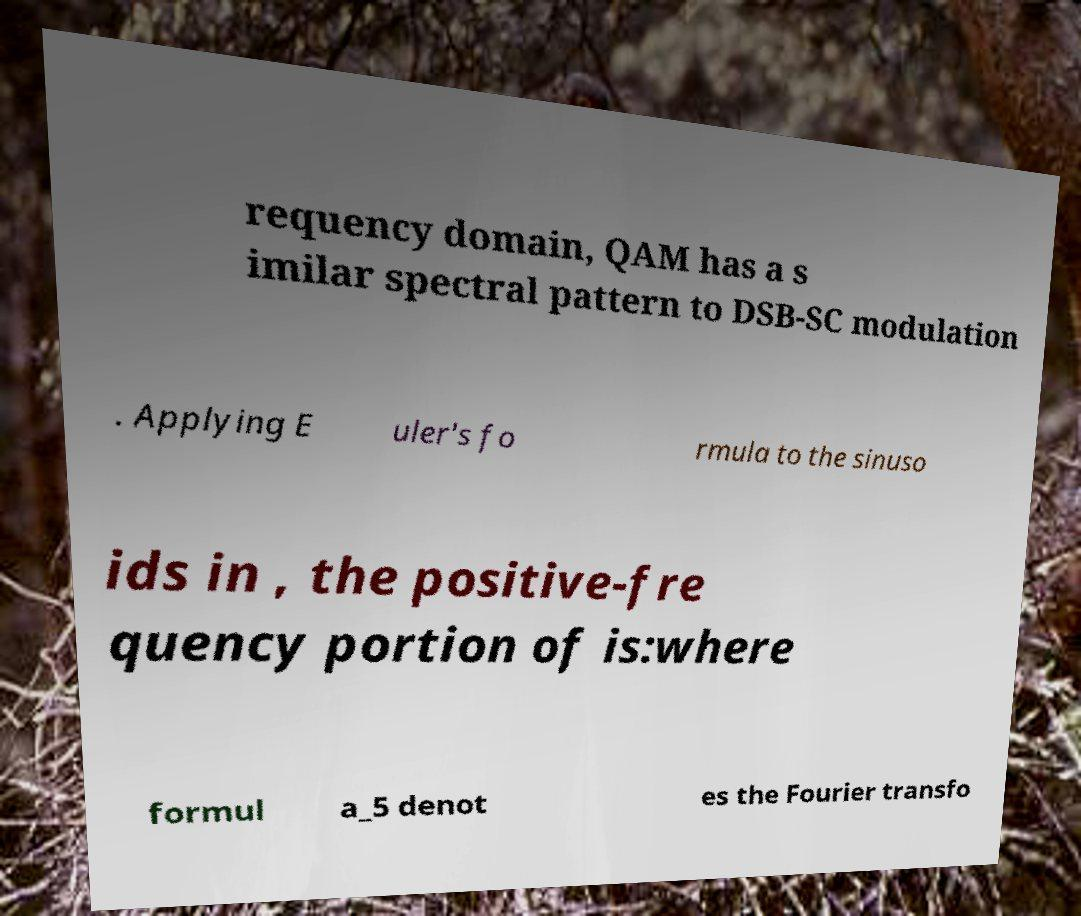Please read and relay the text visible in this image. What does it say? requency domain, QAM has a s imilar spectral pattern to DSB-SC modulation . Applying E uler's fo rmula to the sinuso ids in , the positive-fre quency portion of is:where formul a_5 denot es the Fourier transfo 